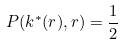Convert formula to latex. <formula><loc_0><loc_0><loc_500><loc_500>P ( k ^ { * } ( r ) , r ) = \frac { 1 } { 2 }</formula> 